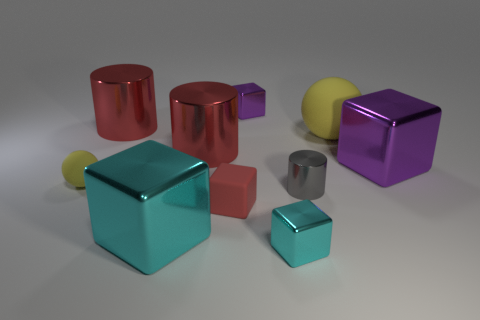Is the shape of the small red object the same as the small purple object?
Keep it short and to the point. Yes. The other purple thing that is made of the same material as the tiny purple object is what size?
Your answer should be compact. Large. Is the number of big green metallic cubes less than the number of big cyan objects?
Provide a succinct answer. Yes. What number of big things are red metallic objects or yellow cylinders?
Provide a short and direct response. 2. What number of shiny blocks are both in front of the red rubber thing and right of the large yellow matte object?
Offer a very short reply. 0. Is the number of tiny purple things greater than the number of small gray matte objects?
Give a very brief answer. Yes. How many other things are the same shape as the big cyan thing?
Your response must be concise. 4. Does the big rubber sphere have the same color as the tiny sphere?
Offer a very short reply. Yes. There is a block that is in front of the gray shiny cylinder and on the right side of the red matte block; what is its material?
Offer a very short reply. Metal. How many small matte cubes are behind the tiny matte thing in front of the ball in front of the big purple block?
Ensure brevity in your answer.  0. 